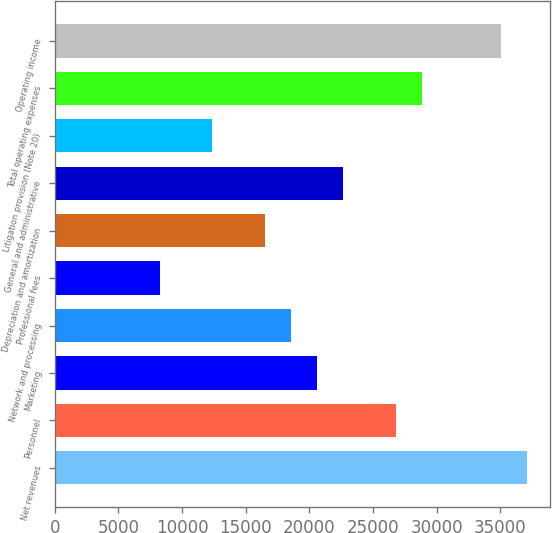<chart> <loc_0><loc_0><loc_500><loc_500><bar_chart><fcel>Net revenues<fcel>Personnel<fcel>Marketing<fcel>Network and processing<fcel>Professional fees<fcel>Depreciation and amortization<fcel>General and administrative<fcel>Litigation provision (Note 20)<fcel>Total operating expenses<fcel>Operating income<nl><fcel>37092.7<fcel>26790.4<fcel>20609<fcel>18548.6<fcel>8246.27<fcel>16488.1<fcel>22669.5<fcel>12367.2<fcel>28850.9<fcel>35032.2<nl></chart> 